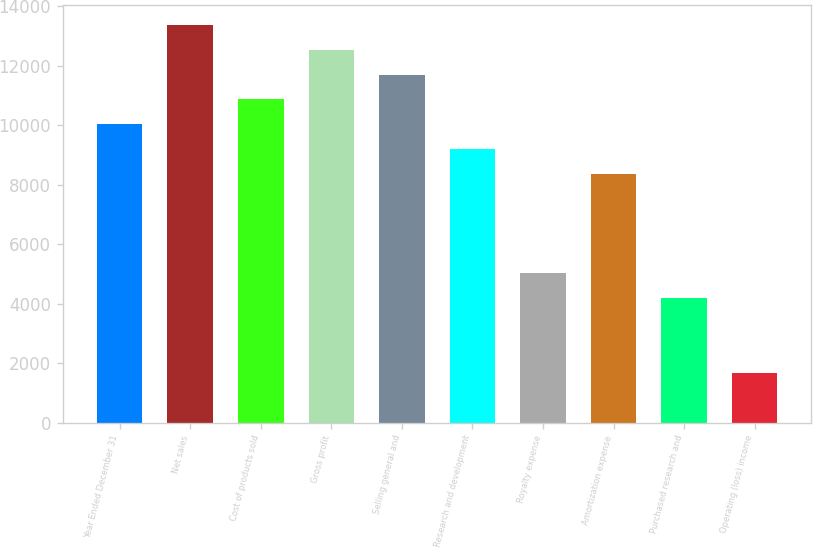Convert chart to OTSL. <chart><loc_0><loc_0><loc_500><loc_500><bar_chart><fcel>Year Ended December 31<fcel>Net sales<fcel>Cost of products sold<fcel>Gross profit<fcel>Selling general and<fcel>Research and development<fcel>Royalty expense<fcel>Amortization expense<fcel>Purchased research and<fcel>Operating (loss) income<nl><fcel>10028.4<fcel>13371<fcel>10864<fcel>12535.4<fcel>11699.7<fcel>9192.7<fcel>5014.35<fcel>8357.03<fcel>4178.68<fcel>1671.67<nl></chart> 